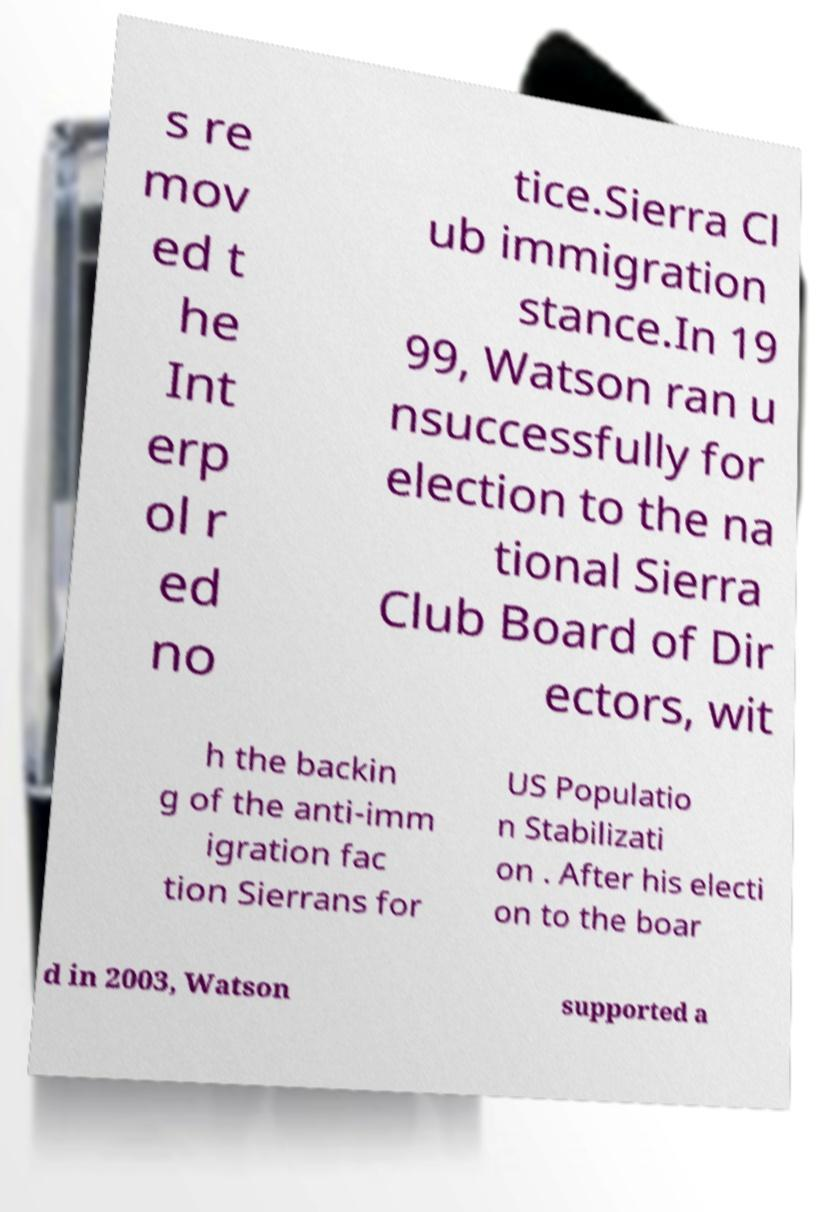Could you extract and type out the text from this image? s re mov ed t he Int erp ol r ed no tice.Sierra Cl ub immigration stance.In 19 99, Watson ran u nsuccessfully for election to the na tional Sierra Club Board of Dir ectors, wit h the backin g of the anti-imm igration fac tion Sierrans for US Populatio n Stabilizati on . After his electi on to the boar d in 2003, Watson supported a 